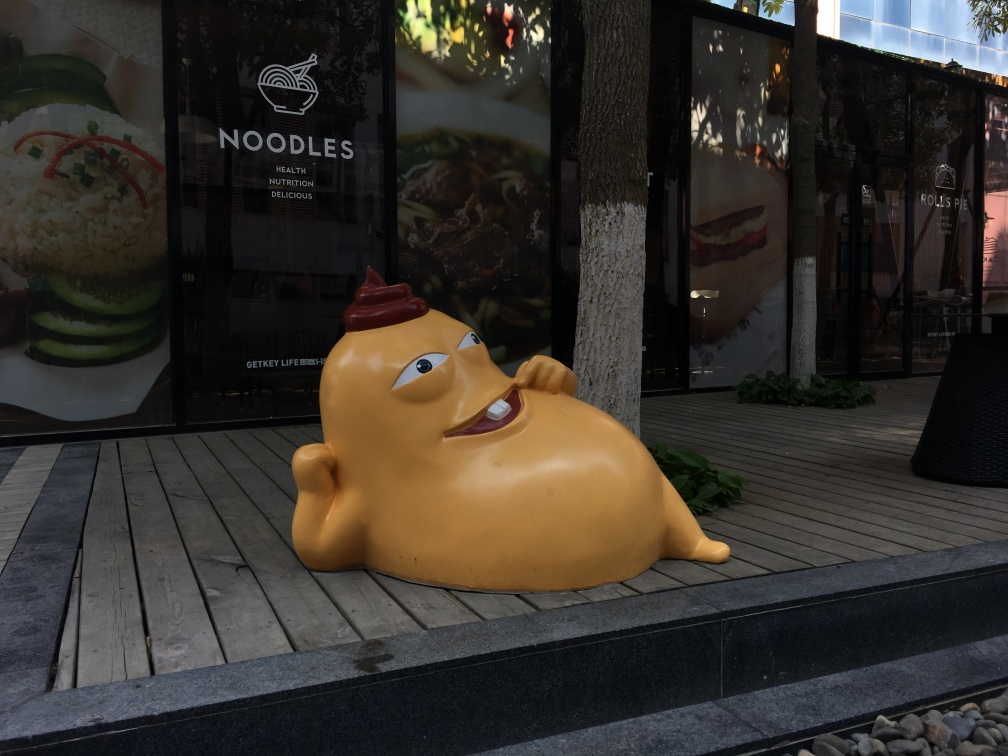Is the texture of the overall environment blurry?
A. No
B. Yes
Answer with the option's letter from the given choices directly.
 A. 